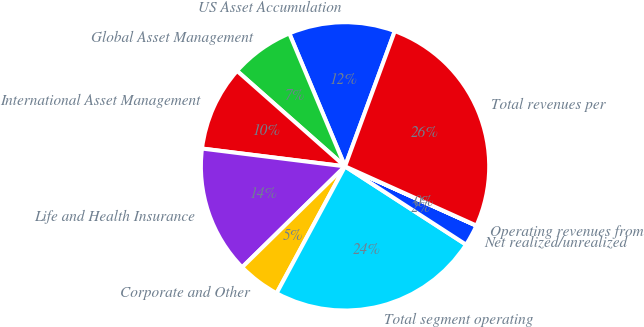Convert chart. <chart><loc_0><loc_0><loc_500><loc_500><pie_chart><fcel>US Asset Accumulation<fcel>Global Asset Management<fcel>International Asset Management<fcel>Life and Health Insurance<fcel>Corporate and Other<fcel>Total segment operating<fcel>Net realized/unrealized<fcel>Operating revenues from<fcel>Total revenues per<nl><fcel>11.93%<fcel>7.16%<fcel>9.55%<fcel>14.32%<fcel>4.78%<fcel>23.74%<fcel>2.39%<fcel>0.01%<fcel>26.13%<nl></chart> 